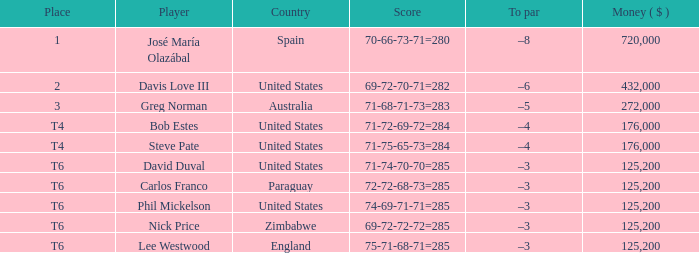Which Score has a Place of 3? 71-68-71-73=283. 